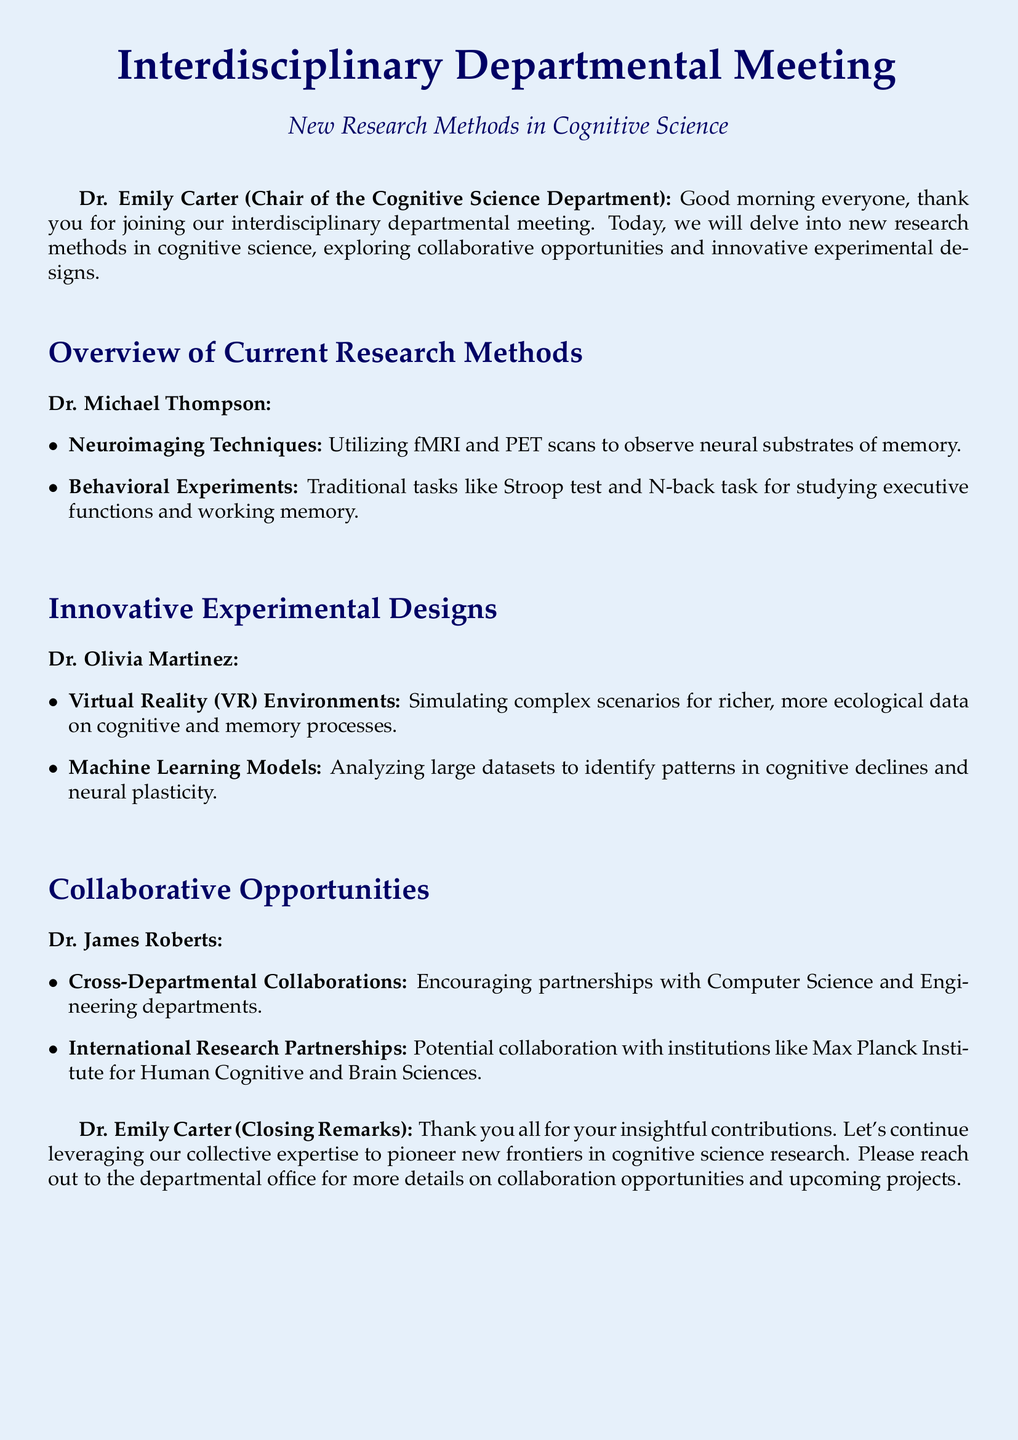What is the title of the meeting? The title of the meeting is provided at the top of the transcript.
Answer: New Research Methods in Cognitive Science Who is the Chair of the Cognitive Science Department? The Chair's name is mentioned at the beginning of the transcript.
Answer: Dr. Emily Carter What innovative method did Dr. Olivia Martinez mention for studying cognitive and memory processes? The method mentioned by Dr. Olivia Martinez is listed under innovative experimental designs.
Answer: Virtual Reality (VR) Environments Which departments are encouraged for cross-departmental collaborations? The specific departments mentioned for collaboration are listed in Dr. James Roberts' section.
Answer: Computer Science and Engineering What potential international institution was referenced for research partnerships? The institution mentioned in the collaborative opportunities section is noted in Dr. James Roberts' comments.
Answer: Max Planck Institute for Human Cognitive and Brain Sciences What two traditional tasks are mentioned under Behavioral Experiments? The specific tasks listed by Dr. Michael Thompson can be found in the overview section.
Answer: Stroop test and N-back task What method is suggested for analyzing large datasets? The method suggested by Dr. Olivia Martinez is included in the innovative experimental designs.
Answer: Machine Learning Models How did Dr. Emily Carter conclude the meeting? Dr. Emily Carter's concluding remarks summarize the meeting's purpose and encourage future collaboration.
Answer: Pioneer new frontiers in cognitive science research 